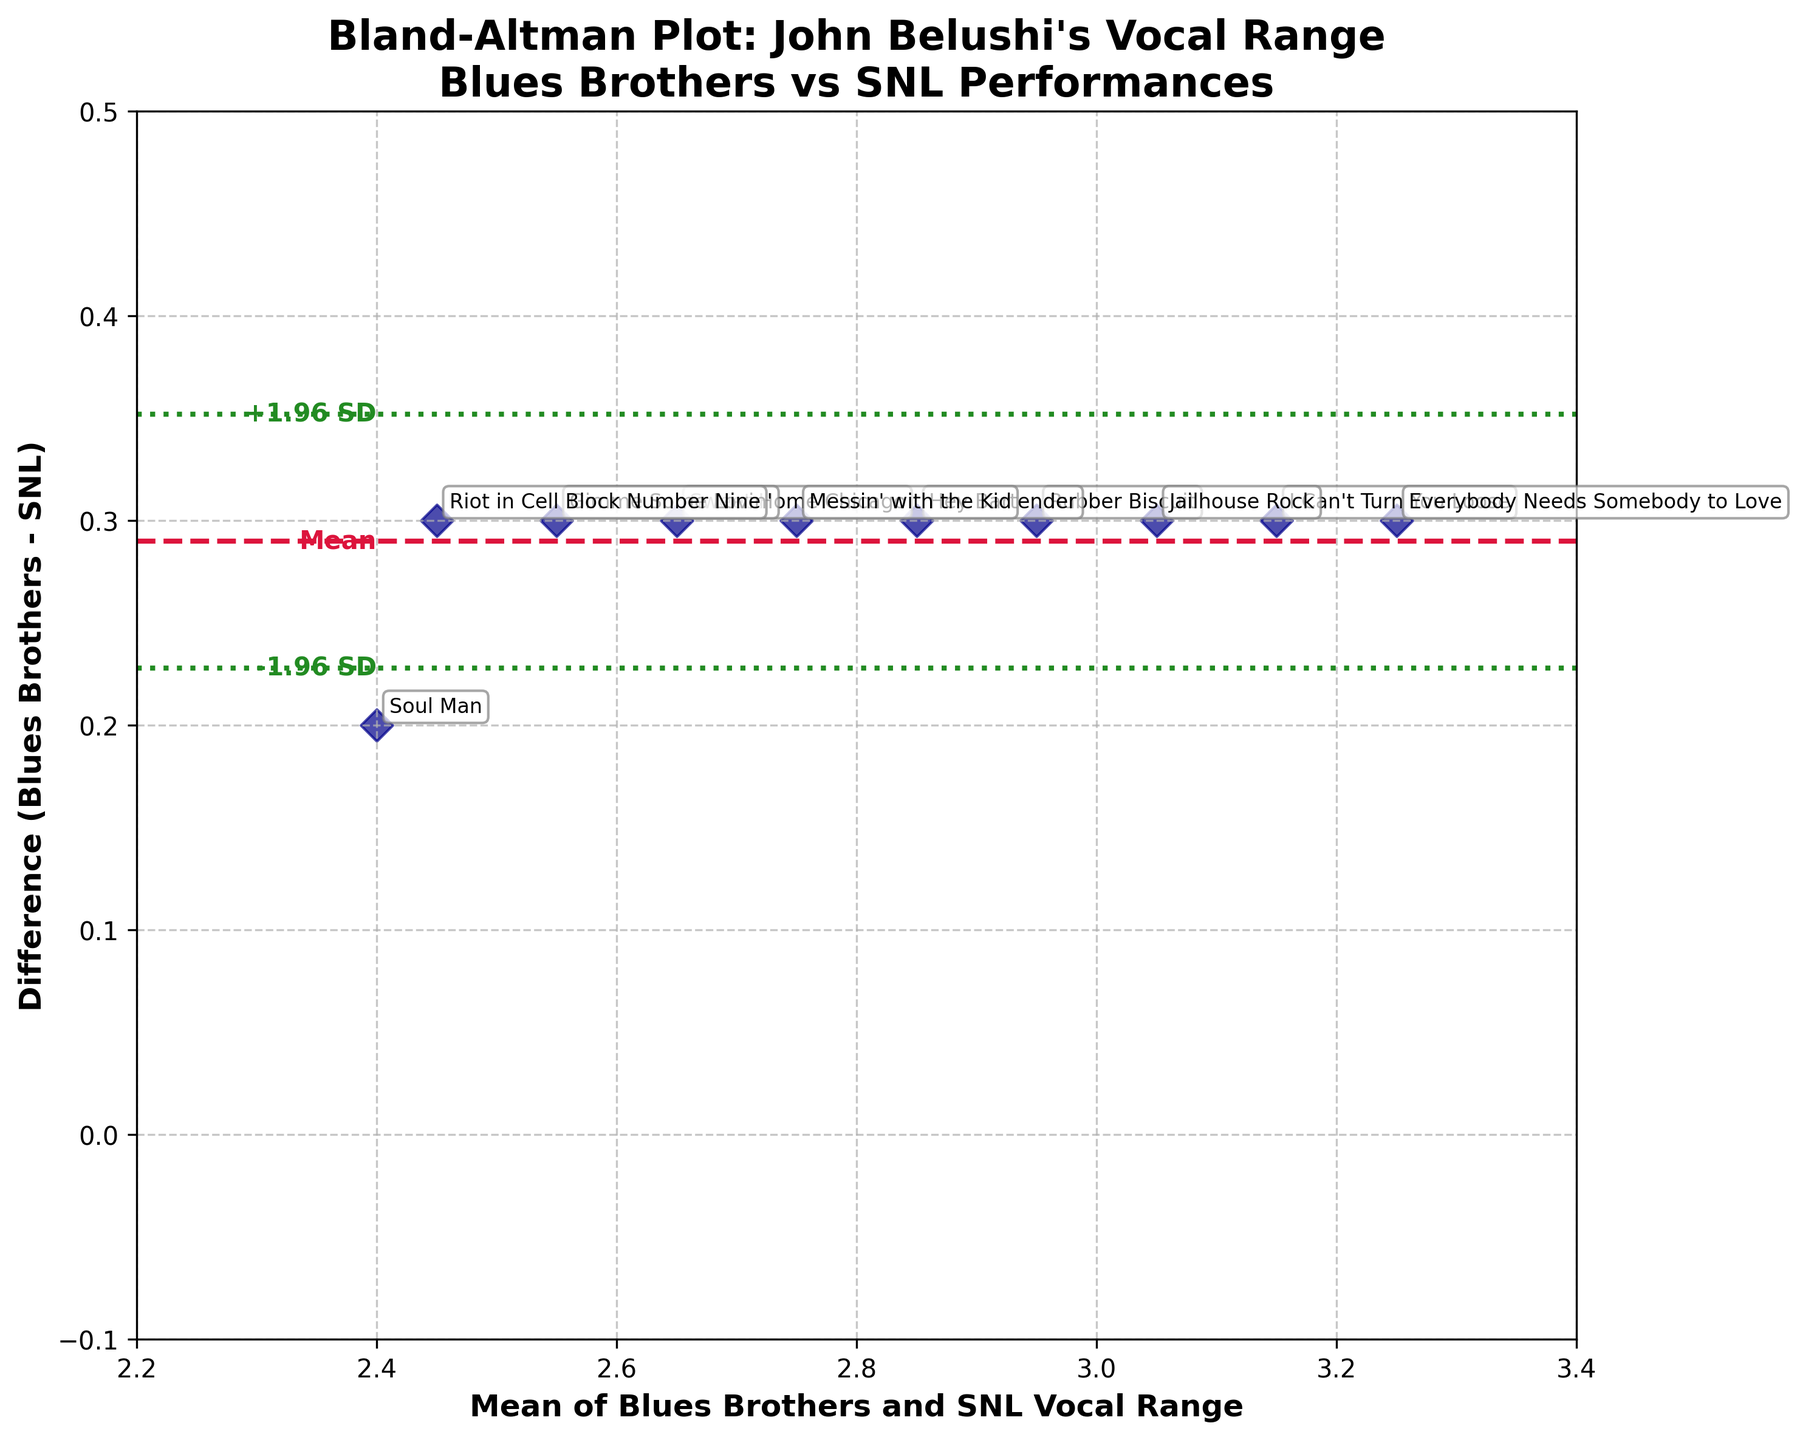which performance has the largest mean vocal range? To determine this, identify the data point furthest to the right. Each scatter presents the mean vocal range for a performance.
Answer: Everybody Needs Somebody to Love what is the mean difference in vocal range between Blues Brothers and SNL performances? This is indicated by the crimson dashed line labeled ‘Mean’. Locate the horizontal dashed line which represents the average difference.
Answer: 0.3 what are the limits of agreement? These are demarcated by the forest green dashed lines labeled '-1.96 SD' and '+1.96 SD'. Identify the positions on the plot for these lines.
Answer: 0.04 and 0.56 which performance has the smallest difference in vocal range between Blues Brothers and SNL? Look for the scatter point closest to the x-axis, as it represents the smallest difference between the two ranges.
Answer: Soul Man how spread out are the differences in vocal ranges? Evaluate the spread of points along the vertical axis to judge the variability in differences. The distance between the points from each other and the mean line indicates the spread.
Answer: relatively small are there any points outside the limits of agreement? Check if any scatters fall outside the forest green dashed lines that indicate the limits of agreement.
Answer: no what is the upper limit of agreement in the plot? This is the higher of the two forest green lines. Identify the line at the highest position vertically among the two that represent the upper and lower limits.
Answer: 0.56 what is the difference in vocal range for 'Hey Bartender'? Find the labeled point for 'Hey Bartender' and observe its vertical position relative to the mean difference line to determine its specific value.
Answer: 0.3 